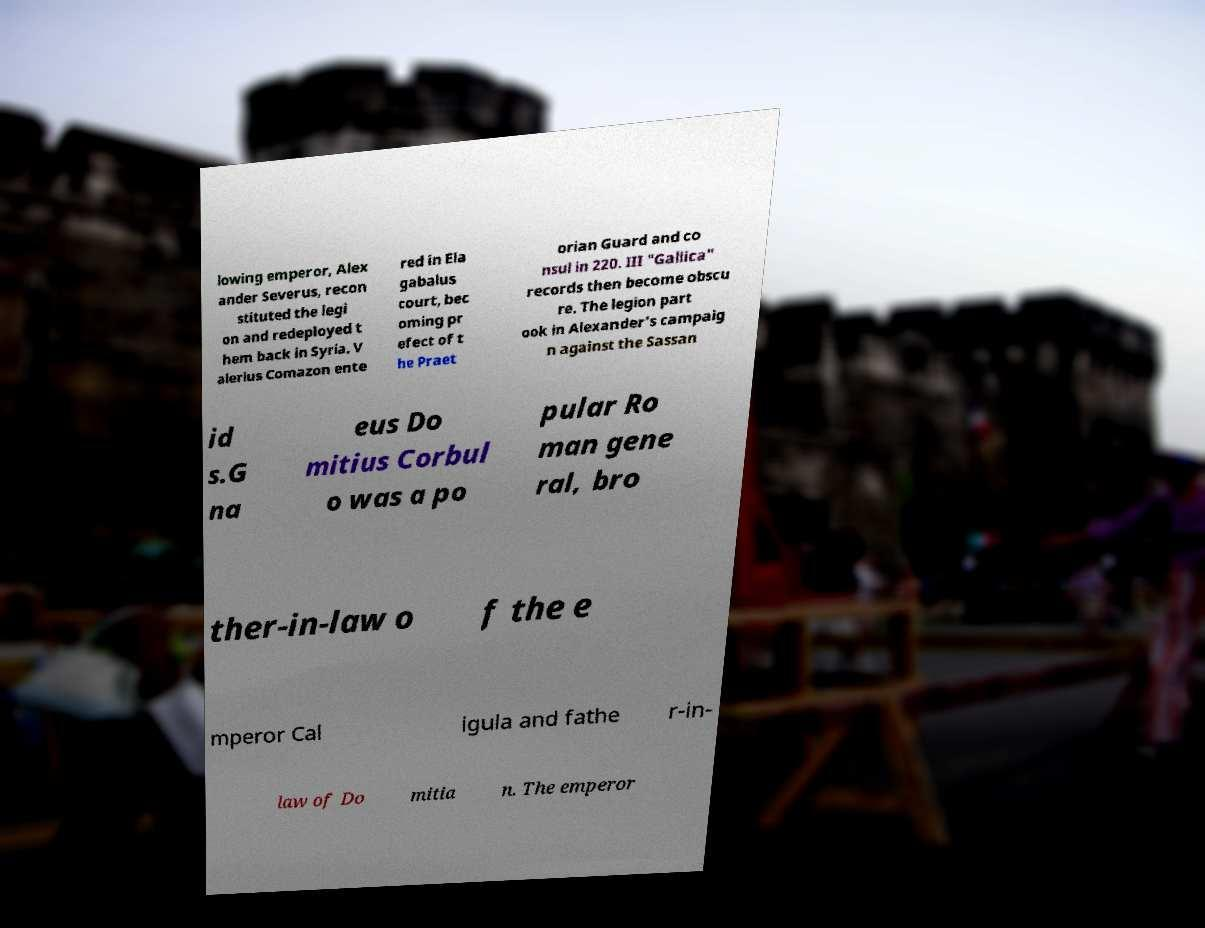There's text embedded in this image that I need extracted. Can you transcribe it verbatim? lowing emperor, Alex ander Severus, recon stituted the legi on and redeployed t hem back in Syria. V alerius Comazon ente red in Ela gabalus court, bec oming pr efect of t he Praet orian Guard and co nsul in 220. III "Gallica" records then become obscu re. The legion part ook in Alexander's campaig n against the Sassan id s.G na eus Do mitius Corbul o was a po pular Ro man gene ral, bro ther-in-law o f the e mperor Cal igula and fathe r-in- law of Do mitia n. The emperor 